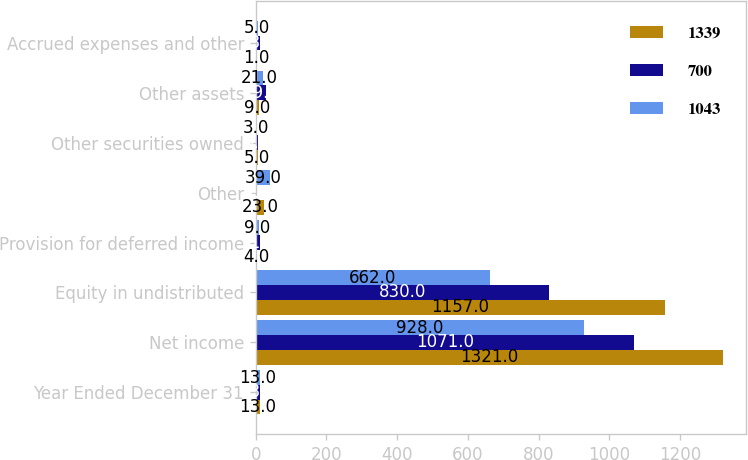Convert chart to OTSL. <chart><loc_0><loc_0><loc_500><loc_500><stacked_bar_chart><ecel><fcel>Year Ended December 31<fcel>Net income<fcel>Equity in undistributed<fcel>Provision for deferred income<fcel>Other<fcel>Other securities owned<fcel>Other assets<fcel>Accrued expenses and other<nl><fcel>1339<fcel>13<fcel>1321<fcel>1157<fcel>4<fcel>23<fcel>5<fcel>9<fcel>1<nl><fcel>700<fcel>13<fcel>1071<fcel>830<fcel>11<fcel>4<fcel>5<fcel>29<fcel>13<nl><fcel>1043<fcel>13<fcel>928<fcel>662<fcel>9<fcel>39<fcel>3<fcel>21<fcel>5<nl></chart> 